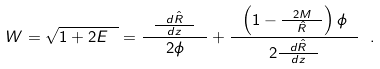Convert formula to latex. <formula><loc_0><loc_0><loc_500><loc_500>W = \sqrt { 1 + 2 E \ } = \frac { \ \frac { \ d \hat { R } \ } { d z } \ } { 2 \phi } + \frac { \ \left ( 1 - \frac { \ 2 M \ } { \hat { R } } \right ) \phi \ } { 2 \frac { \ d \hat { R } \ } { d z } } \ .</formula> 